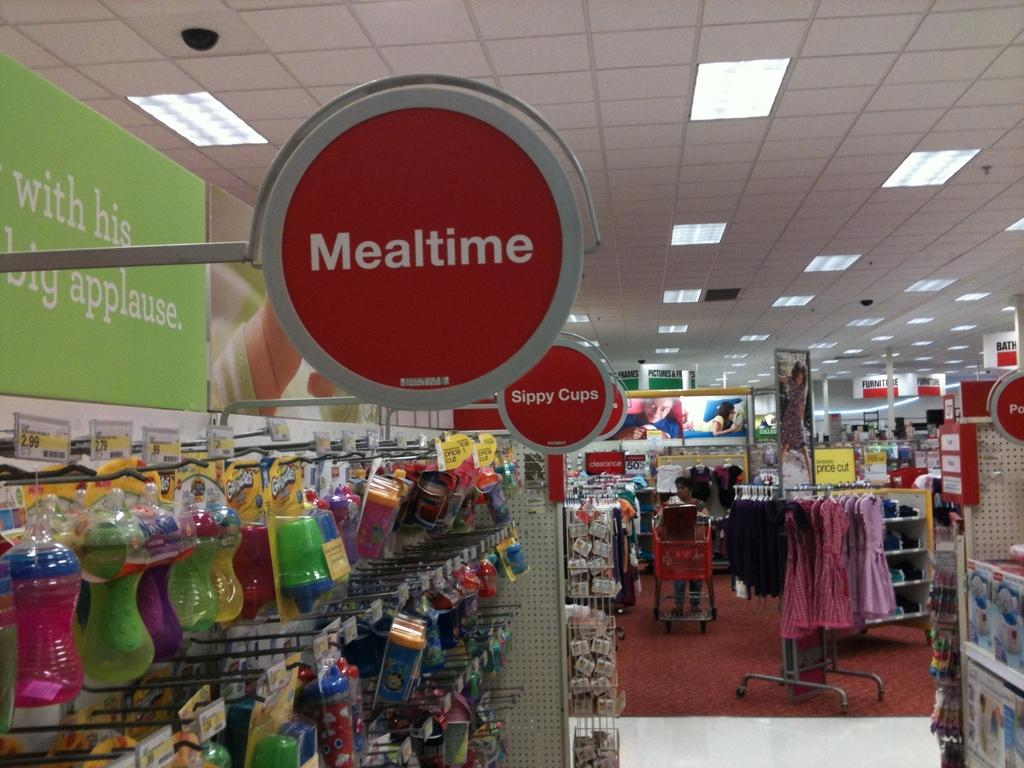<image>
Offer a succinct explanation of the picture presented. an aisle in a store with the words mealtime and supply cups displaying in red 